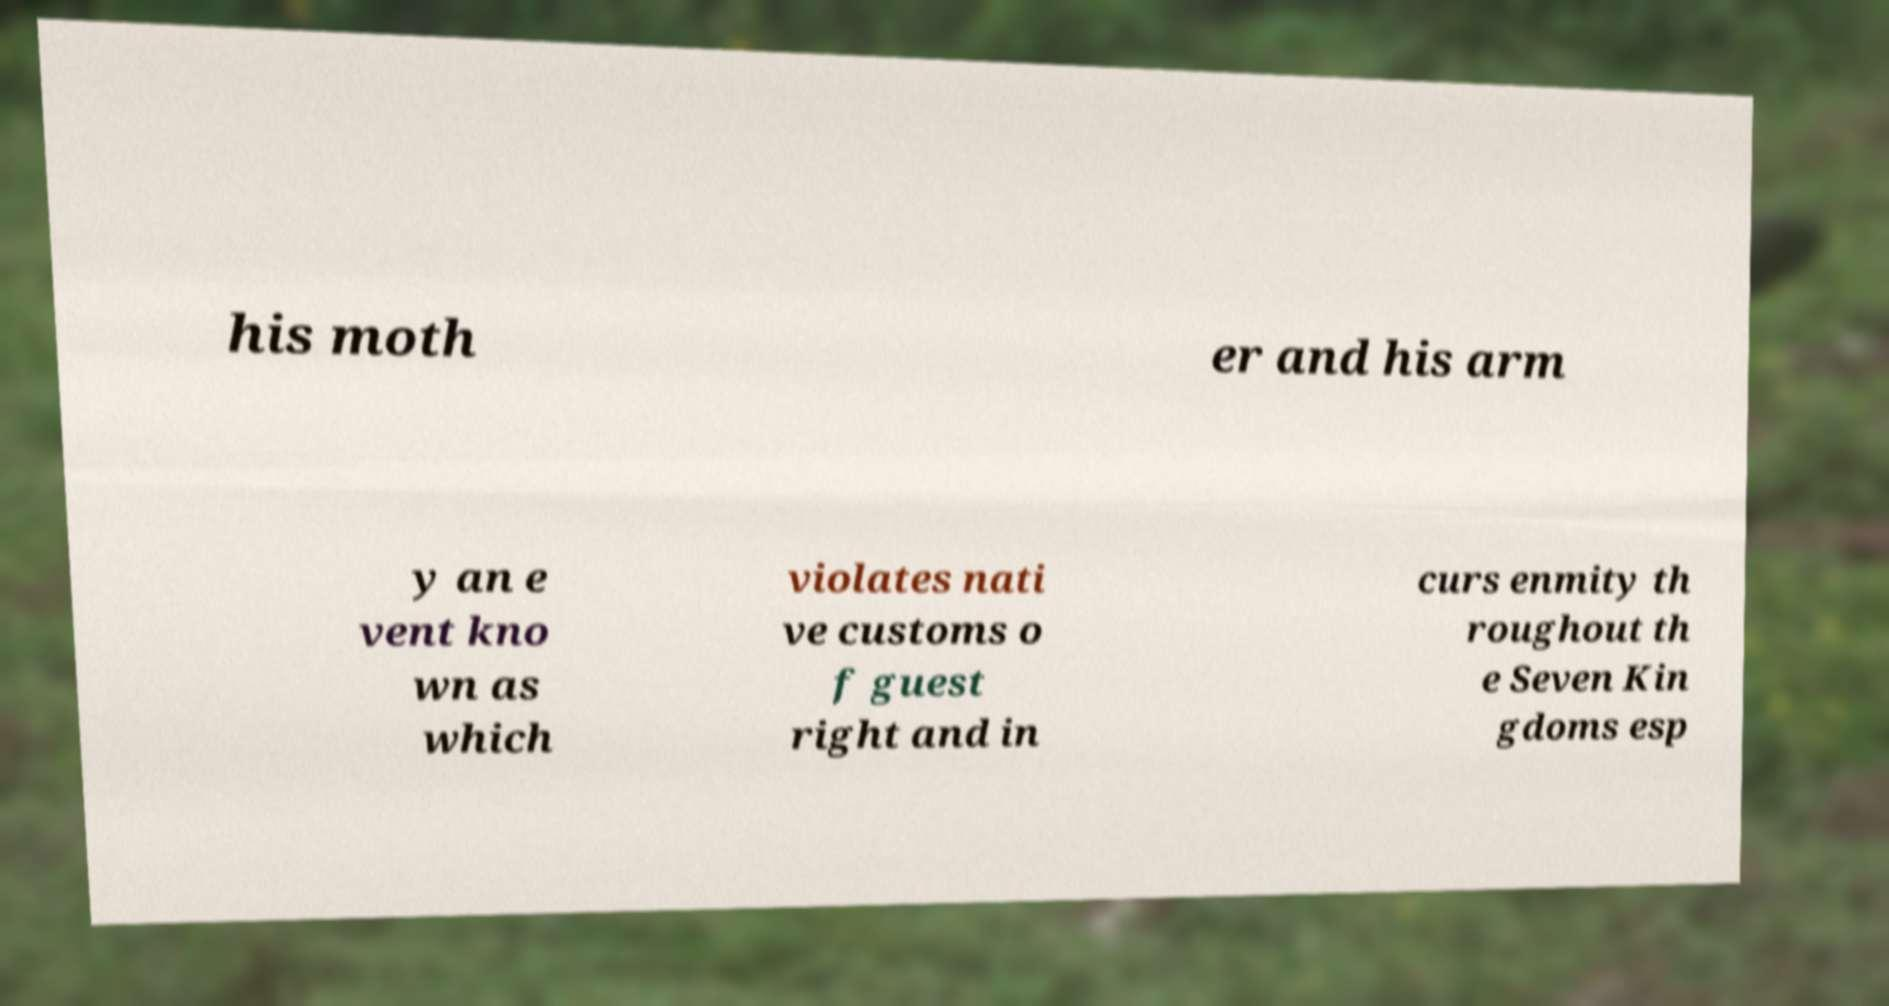What messages or text are displayed in this image? I need them in a readable, typed format. his moth er and his arm y an e vent kno wn as which violates nati ve customs o f guest right and in curs enmity th roughout th e Seven Kin gdoms esp 